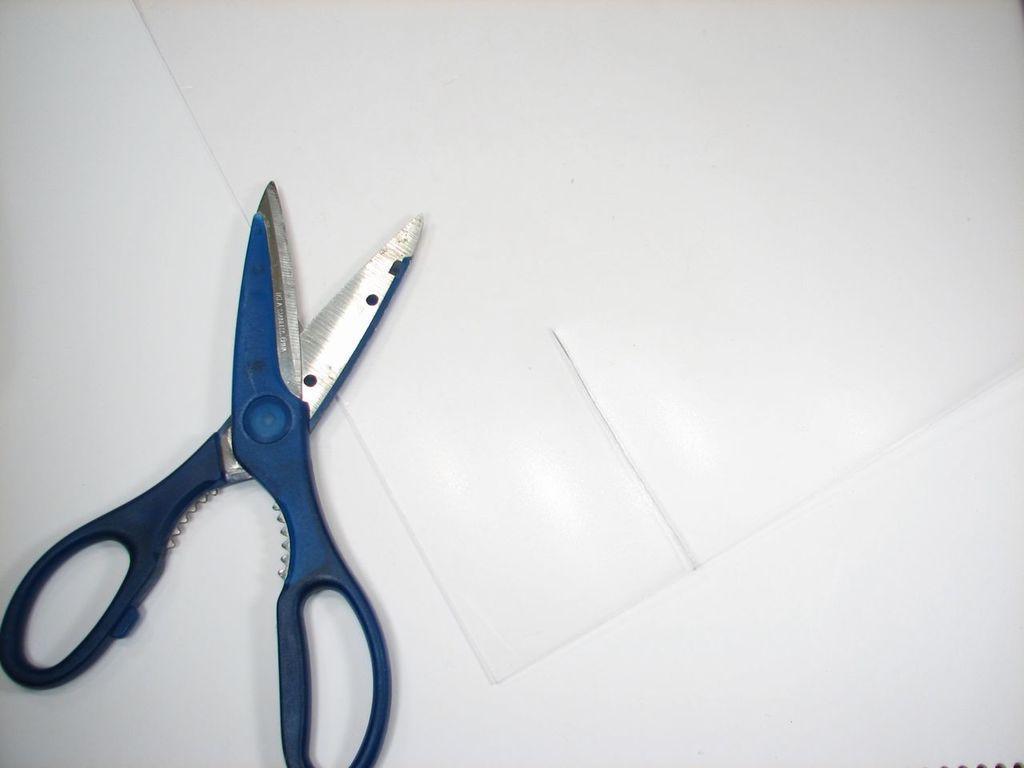Describe this image in one or two sentences. In this image we can see scissors and paper placed on the table. 